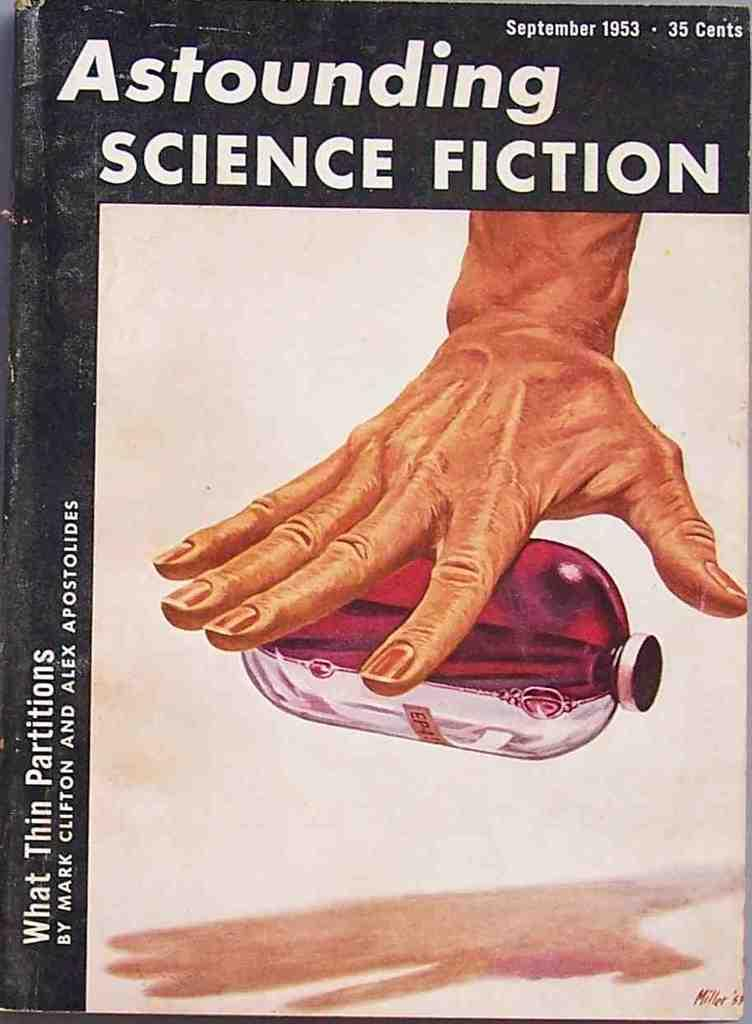<image>
Provide a brief description of the given image. a book that is called Astounding Science Fiction 